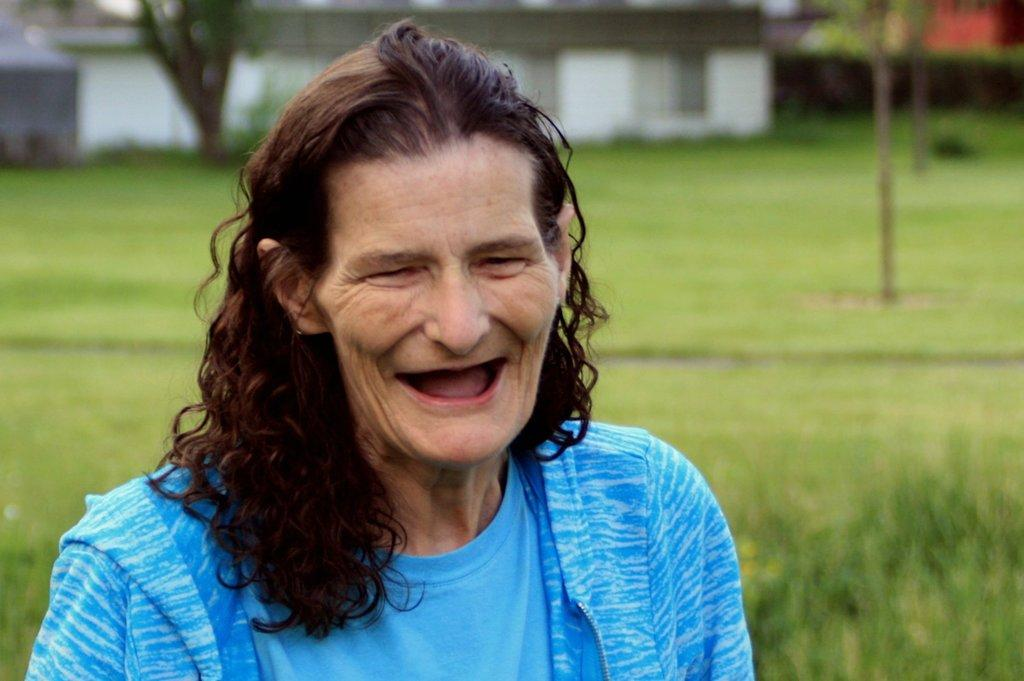Who is present in the image? There is a woman in the image. What is the woman's expression? The woman is smiling. What type of terrain is visible in the image? There is grass on the ground. What can be seen in the background of the image? There is a building and trees in the background of the image. What type of cabbage is being harvested in the image? There is no cabbage present in the image. Can you tell me when the woman's baby was born based on the image? The image does not provide any information about the woman's baby or its birth. What kind of pie is being served on the table in the image? There is no table or pie present in the image. 